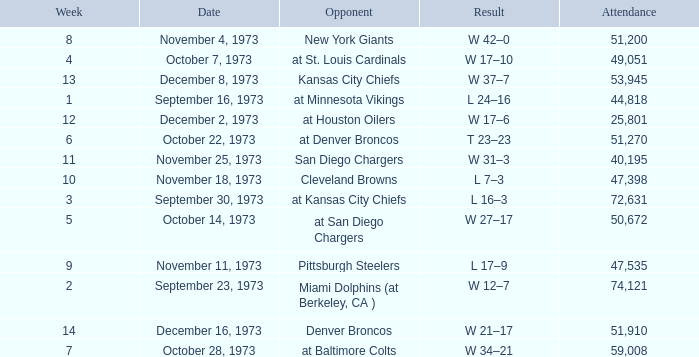What is the result later than week 13? W 21–17. 